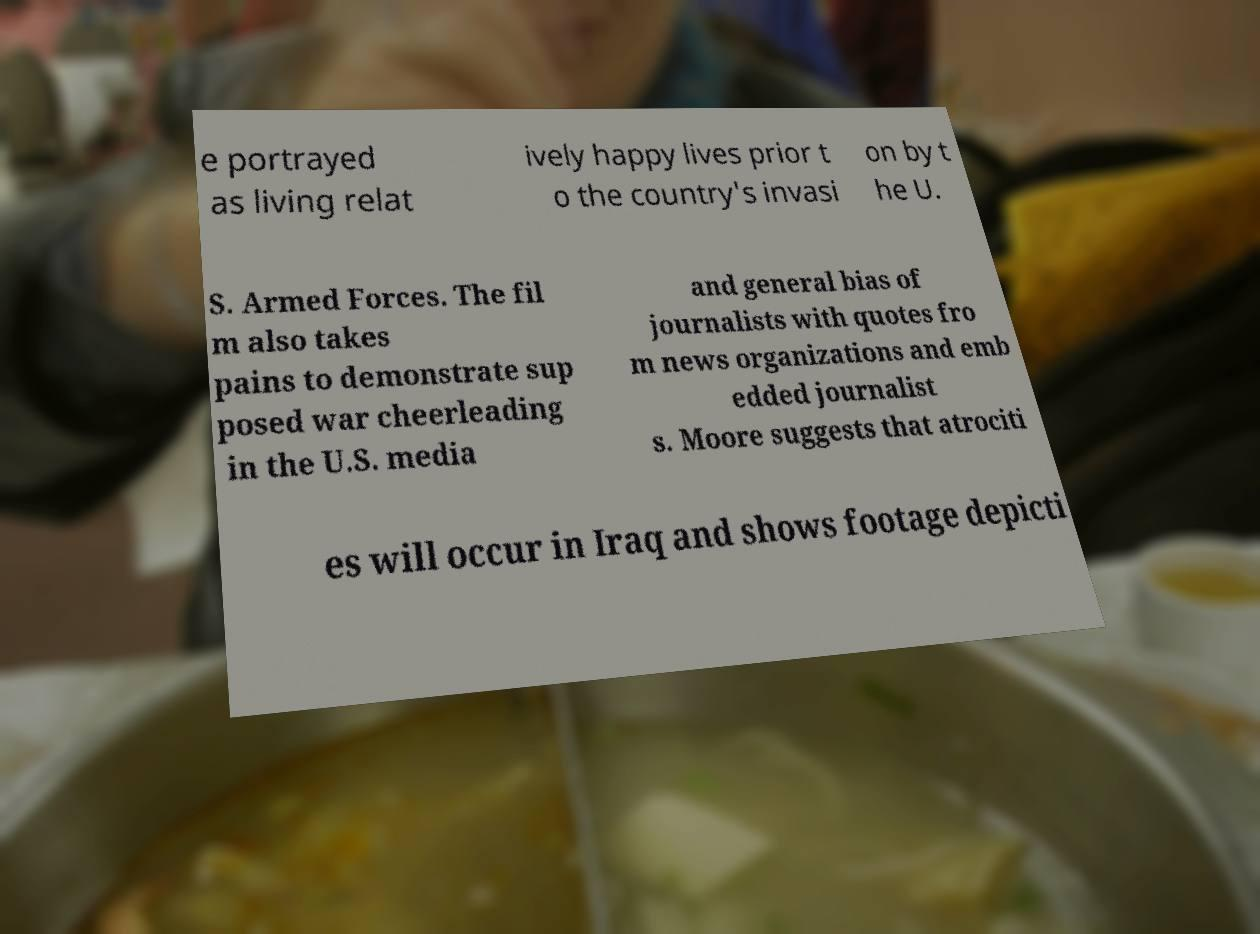What messages or text are displayed in this image? I need them in a readable, typed format. e portrayed as living relat ively happy lives prior t o the country's invasi on by t he U. S. Armed Forces. The fil m also takes pains to demonstrate sup posed war cheerleading in the U.S. media and general bias of journalists with quotes fro m news organizations and emb edded journalist s. Moore suggests that atrociti es will occur in Iraq and shows footage depicti 